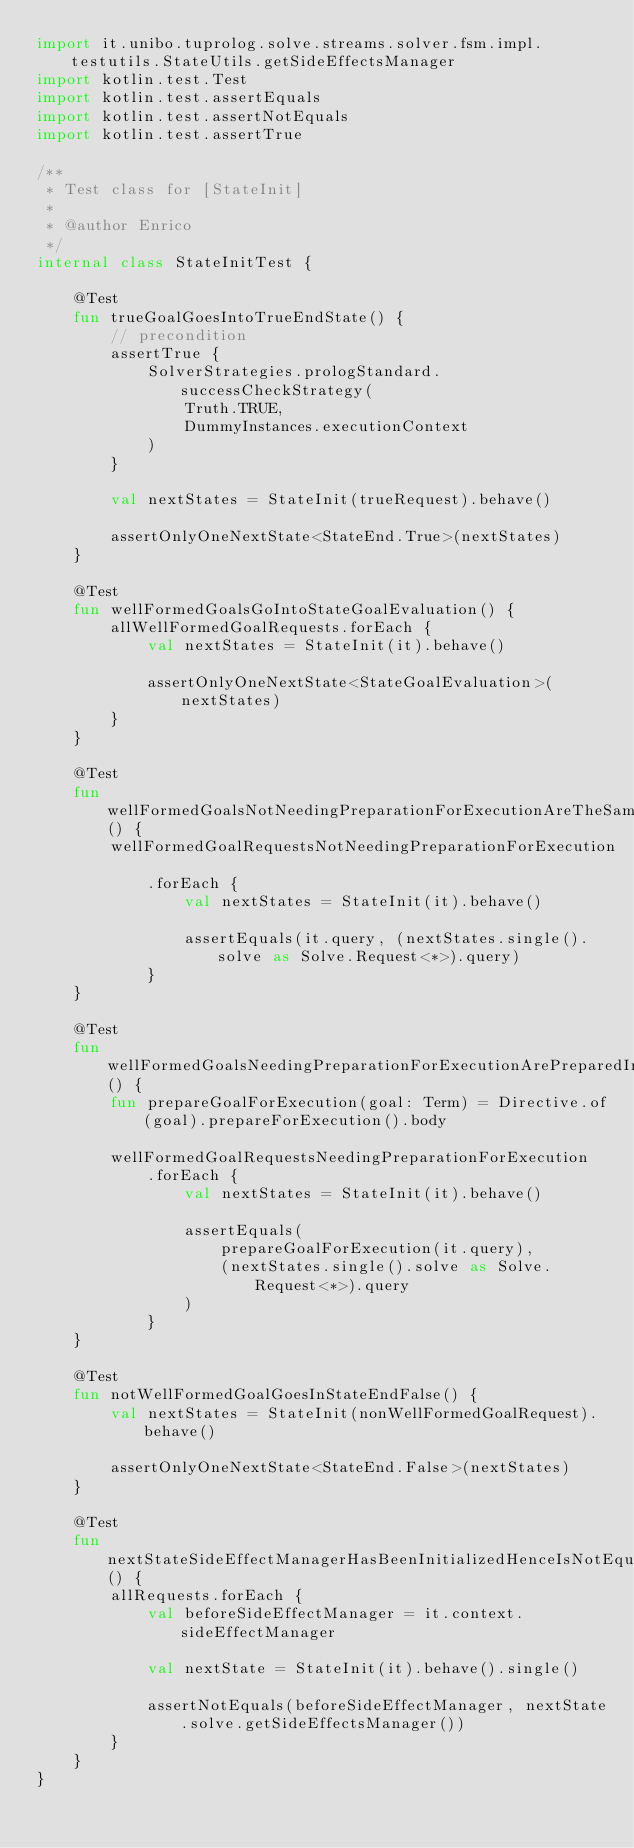<code> <loc_0><loc_0><loc_500><loc_500><_Kotlin_>import it.unibo.tuprolog.solve.streams.solver.fsm.impl.testutils.StateUtils.getSideEffectsManager
import kotlin.test.Test
import kotlin.test.assertEquals
import kotlin.test.assertNotEquals
import kotlin.test.assertTrue

/**
 * Test class for [StateInit]
 *
 * @author Enrico
 */
internal class StateInitTest {

    @Test
    fun trueGoalGoesIntoTrueEndState() {
        // precondition
        assertTrue {
            SolverStrategies.prologStandard.successCheckStrategy(
                Truth.TRUE,
                DummyInstances.executionContext
            )
        }

        val nextStates = StateInit(trueRequest).behave()

        assertOnlyOneNextState<StateEnd.True>(nextStates)
    }

    @Test
    fun wellFormedGoalsGoIntoStateGoalEvaluation() {
        allWellFormedGoalRequests.forEach {
            val nextStates = StateInit(it).behave()

            assertOnlyOneNextState<StateGoalEvaluation>(nextStates)
        }
    }

    @Test
    fun wellFormedGoalsNotNeedingPreparationForExecutionAreTheSameInNextStateRequest() {
        wellFormedGoalRequestsNotNeedingPreparationForExecution
            .forEach {
                val nextStates = StateInit(it).behave()

                assertEquals(it.query, (nextStates.single().solve as Solve.Request<*>).query)
            }
    }

    @Test
    fun wellFormedGoalsNeedingPreparationForExecutionArePreparedInNextStateRequest() {
        fun prepareGoalForExecution(goal: Term) = Directive.of(goal).prepareForExecution().body

        wellFormedGoalRequestsNeedingPreparationForExecution
            .forEach {
                val nextStates = StateInit(it).behave()

                assertEquals(
                    prepareGoalForExecution(it.query),
                    (nextStates.single().solve as Solve.Request<*>).query
                )
            }
    }

    @Test
    fun notWellFormedGoalGoesInStateEndFalse() {
        val nextStates = StateInit(nonWellFormedGoalRequest).behave()

        assertOnlyOneNextState<StateEnd.False>(nextStates)
    }

    @Test
    fun nextStateSideEffectManagerHasBeenInitializedHenceIsNotEquals() {
        allRequests.forEach {
            val beforeSideEffectManager = it.context.sideEffectManager

            val nextState = StateInit(it).behave().single()

            assertNotEquals(beforeSideEffectManager, nextState.solve.getSideEffectsManager())
        }
    }
}
</code> 